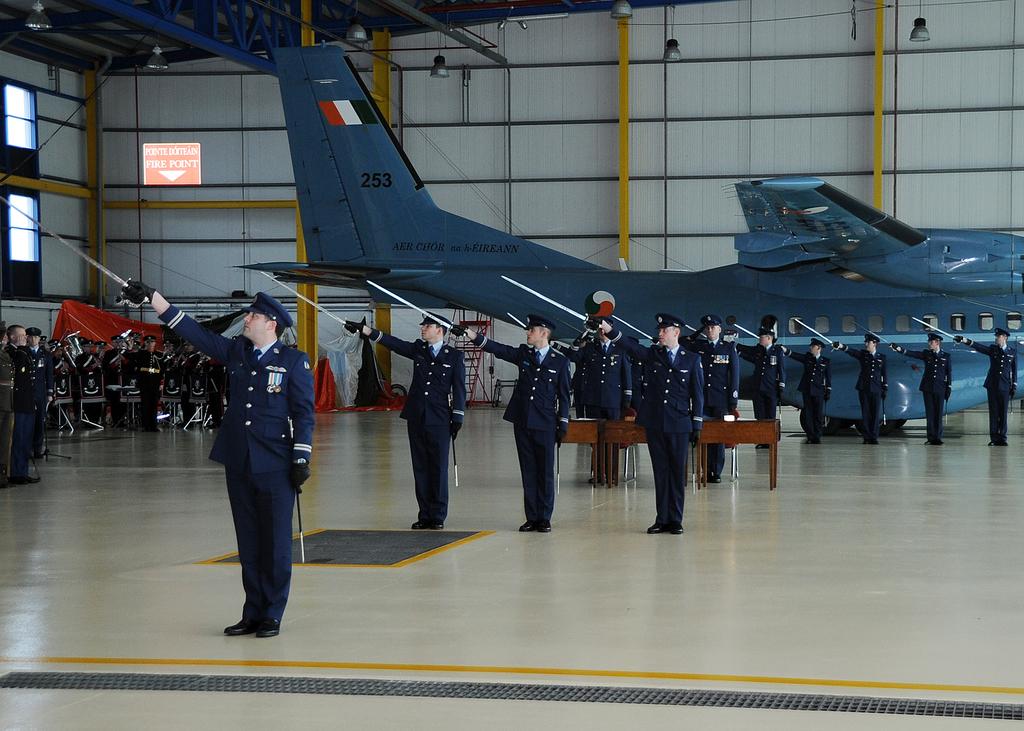What number is on the plane?
Give a very brief answer. 253. 